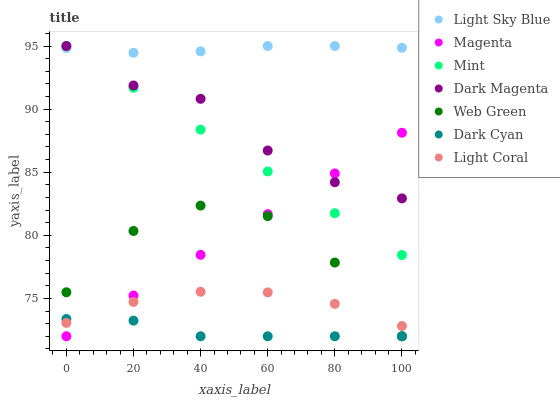Does Dark Cyan have the minimum area under the curve?
Answer yes or no. Yes. Does Light Sky Blue have the maximum area under the curve?
Answer yes or no. Yes. Does Web Green have the minimum area under the curve?
Answer yes or no. No. Does Web Green have the maximum area under the curve?
Answer yes or no. No. Is Magenta the smoothest?
Answer yes or no. Yes. Is Web Green the roughest?
Answer yes or no. Yes. Is Light Coral the smoothest?
Answer yes or no. No. Is Light Coral the roughest?
Answer yes or no. No. Does Web Green have the lowest value?
Answer yes or no. Yes. Does Light Coral have the lowest value?
Answer yes or no. No. Does Mint have the highest value?
Answer yes or no. Yes. Does Web Green have the highest value?
Answer yes or no. No. Is Light Coral less than Light Sky Blue?
Answer yes or no. Yes. Is Light Sky Blue greater than Web Green?
Answer yes or no. Yes. Does Light Coral intersect Magenta?
Answer yes or no. Yes. Is Light Coral less than Magenta?
Answer yes or no. No. Is Light Coral greater than Magenta?
Answer yes or no. No. Does Light Coral intersect Light Sky Blue?
Answer yes or no. No. 